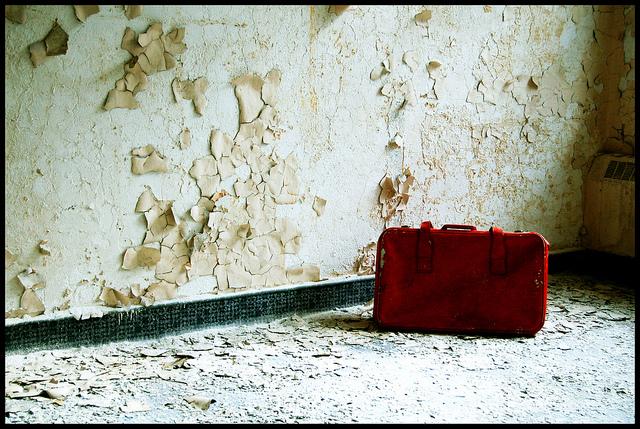What room would you find this?
Be succinct. Basement. What is the color of the bag?
Concise answer only. Red. Is the wall crumbling?
Short answer required. Yes. Is this black and white?
Give a very brief answer. No. IS there a heating/cooling unit in the room?
Quick response, please. Yes. 